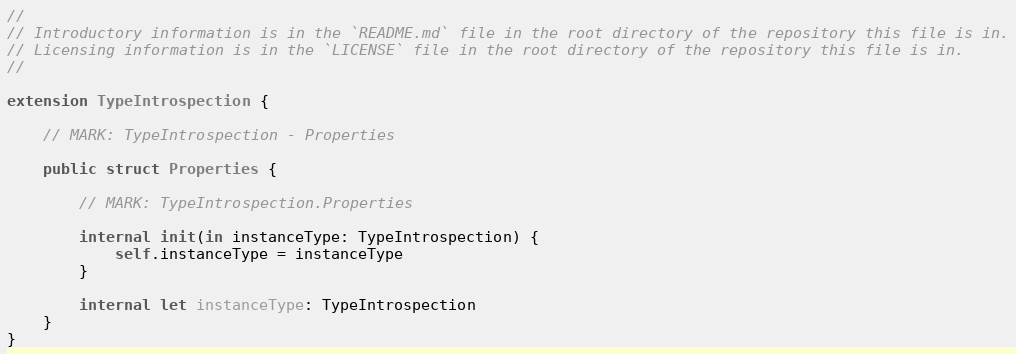<code> <loc_0><loc_0><loc_500><loc_500><_Swift_>//
// Introductory information is in the `README.md` file in the root directory of the repository this file is in.
// Licensing information is in the `LICENSE` file in the root directory of the repository this file is in.
//

extension TypeIntrospection {

    // MARK: TypeIntrospection - Properties

    public struct Properties {

        // MARK: TypeIntrospection.Properties

        internal init(in instanceType: TypeIntrospection) {
            self.instanceType = instanceType
        }

        internal let instanceType: TypeIntrospection
    }
}
</code> 